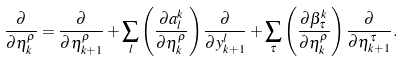Convert formula to latex. <formula><loc_0><loc_0><loc_500><loc_500>\frac { \partial } { \partial \eta ^ { \rho } _ { k } } = \frac { \partial } { \partial \eta ^ { \rho } _ { k + 1 } } + \sum _ { l } \left ( \frac { \partial a ^ { k } _ { l } } { \partial \eta ^ { \rho } _ { k } } \right ) \frac { \partial } { \partial y ^ { l } _ { k + 1 } } + \sum _ { \tau } \left ( \frac { \partial \beta ^ { k } _ { \tau } } { \partial \eta ^ { \rho } _ { k } } \right ) \frac { \partial } { \partial \eta ^ { \tau } _ { k + 1 } } .</formula> 